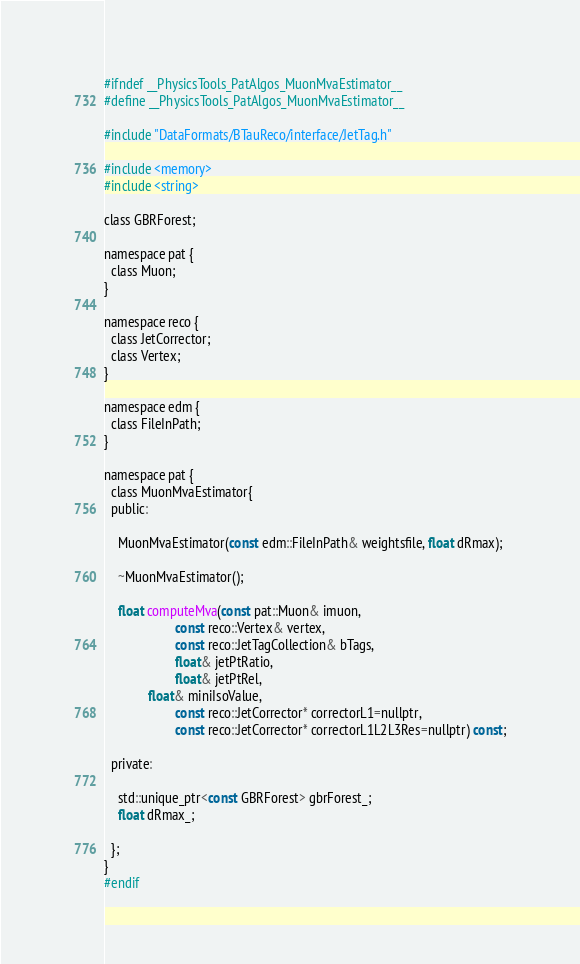Convert code to text. <code><loc_0><loc_0><loc_500><loc_500><_C_>#ifndef __PhysicsTools_PatAlgos_MuonMvaEstimator__
#define __PhysicsTools_PatAlgos_MuonMvaEstimator__

#include "DataFormats/BTauReco/interface/JetTag.h"

#include <memory>
#include <string>

class GBRForest;

namespace pat {
  class Muon;
}

namespace reco {
  class JetCorrector;
  class Vertex;
}

namespace edm {
  class FileInPath;
}

namespace pat {
  class MuonMvaEstimator{
  public:

    MuonMvaEstimator(const edm::FileInPath& weightsfile, float dRmax);

    ~MuonMvaEstimator();

    float computeMva(const pat::Muon& imuon,
                     const reco::Vertex& vertex,
                     const reco::JetTagCollection& bTags,
                     float& jetPtRatio,
                     float& jetPtRel,
		     float& miniIsoValue,
                     const reco::JetCorrector* correctorL1=nullptr,
                     const reco::JetCorrector* correctorL1L2L3Res=nullptr) const;

  private:

    std::unique_ptr<const GBRForest> gbrForest_;
    float dRmax_;

  };
}
#endif
</code> 